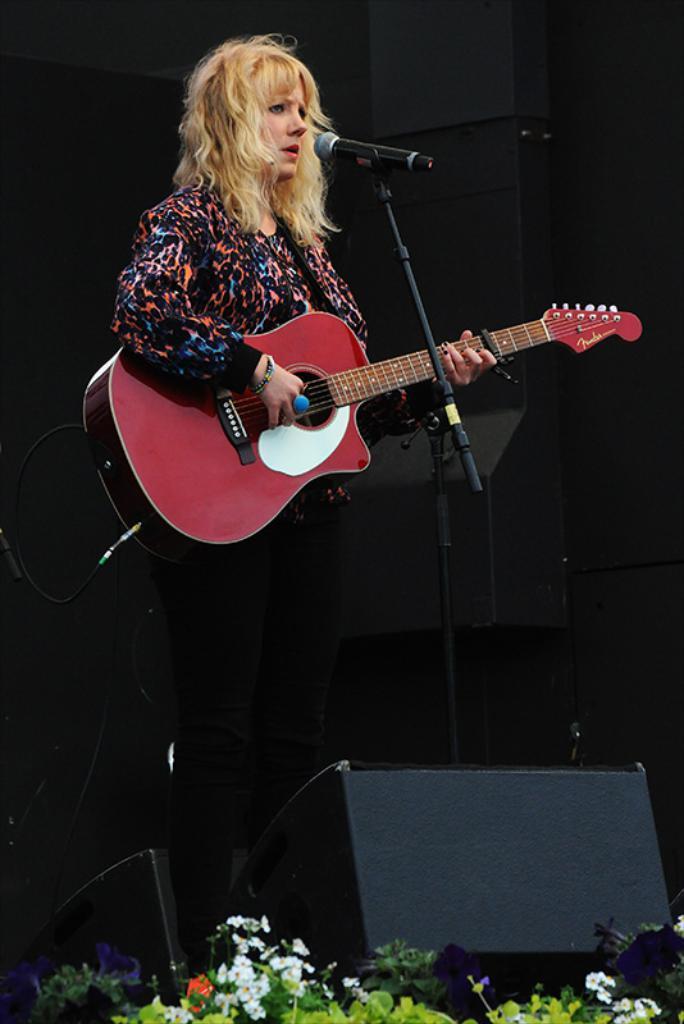How would you summarize this image in a sentence or two? In this Image I see a woman who is standing and she is holding a guitar and there is a mic in front of her, I can also see few plants over here. 